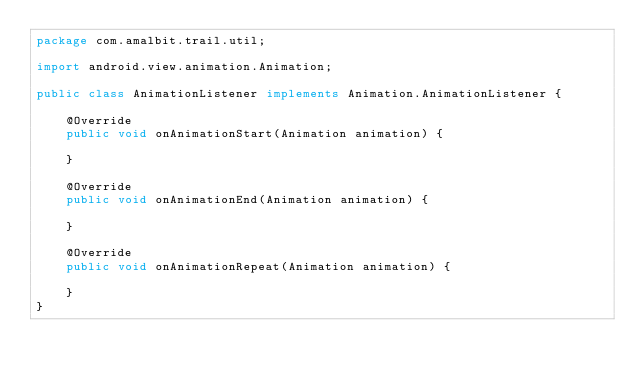Convert code to text. <code><loc_0><loc_0><loc_500><loc_500><_Java_>package com.amalbit.trail.util;

import android.view.animation.Animation;

public class AnimationListener implements Animation.AnimationListener {

    @Override
    public void onAnimationStart(Animation animation) {

    }

    @Override
    public void onAnimationEnd(Animation animation) {

    }

    @Override
    public void onAnimationRepeat(Animation animation) {

    }
}
</code> 